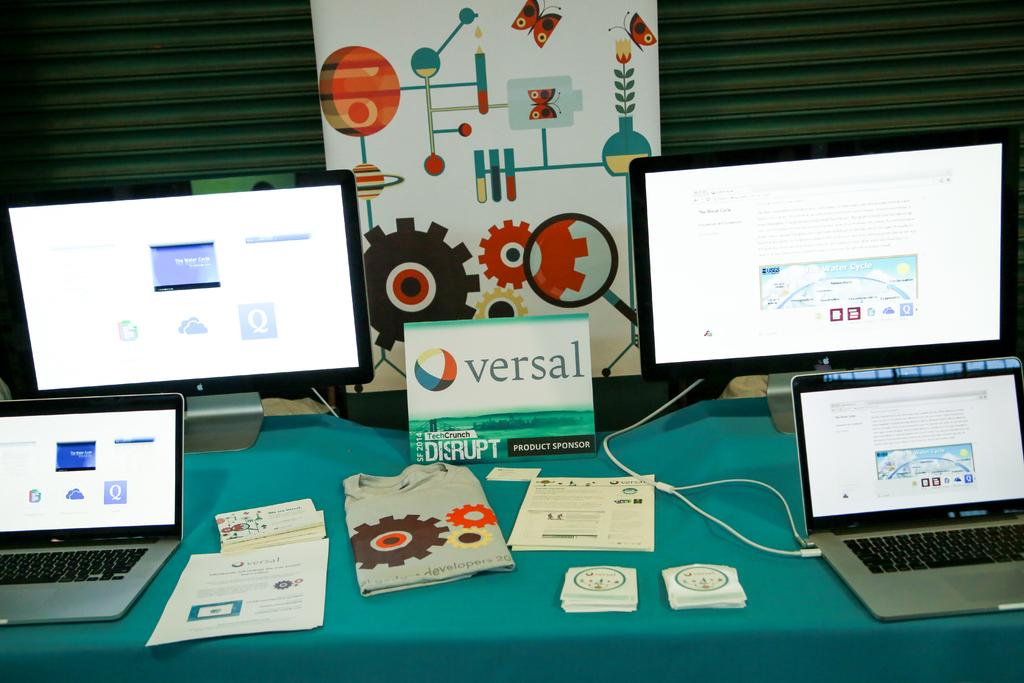<image>
Present a compact description of the photo's key features. A card is on display between two computers that says "versal" 